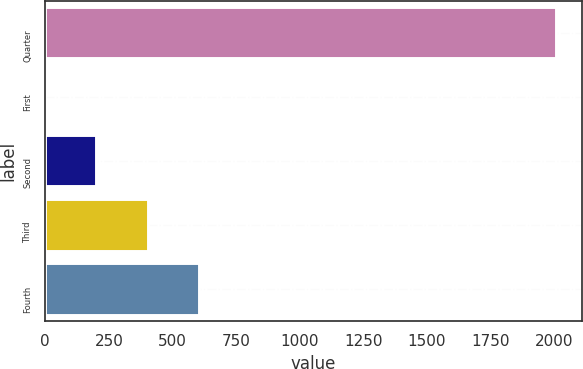Convert chart to OTSL. <chart><loc_0><loc_0><loc_500><loc_500><bar_chart><fcel>Quarter<fcel>First<fcel>Second<fcel>Third<fcel>Fourth<nl><fcel>2010<fcel>0.25<fcel>201.23<fcel>402.21<fcel>603.18<nl></chart> 